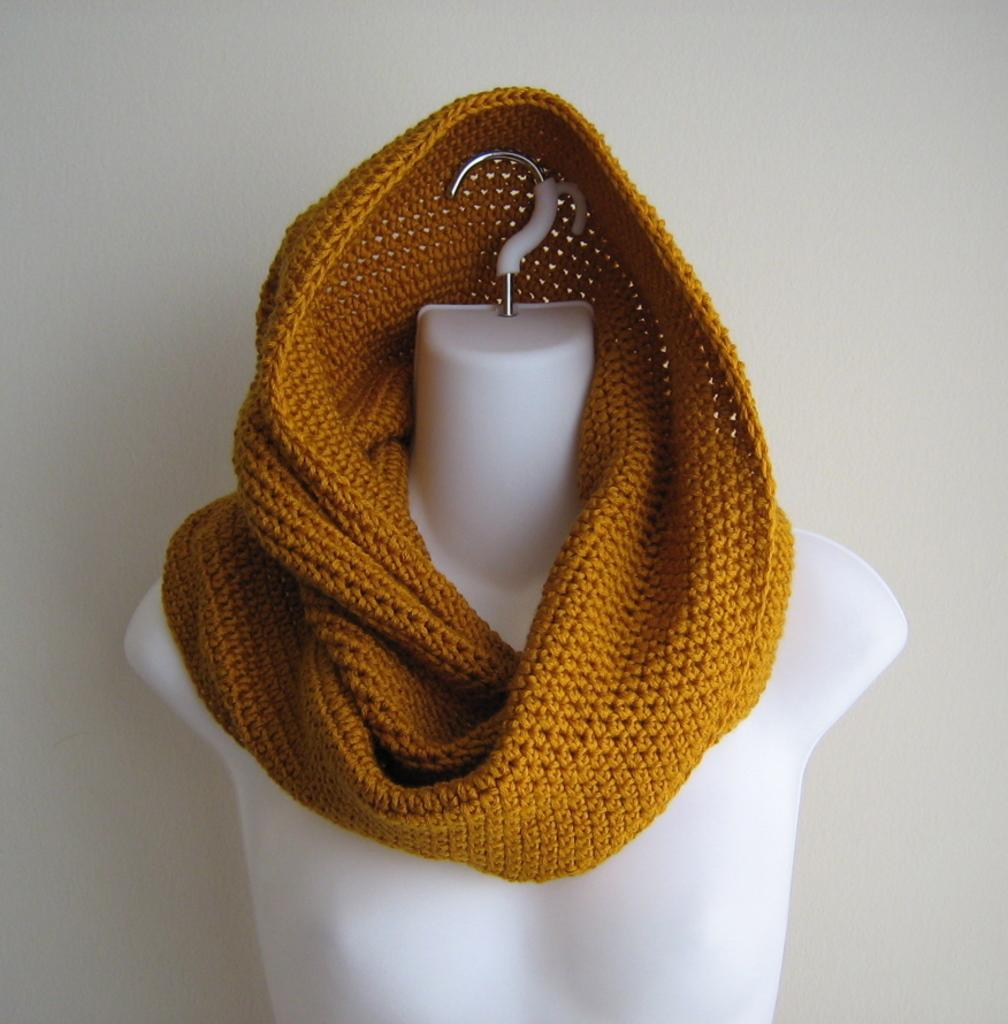What color is the scarf in the image? The scarf in the image is brown. What is the scarf placed on in the image? The scarf is on a mannequin. What can be seen in the background of the image? There is a wall in the background of the image. What type of scent can be detected from the scarf in the image? There is no information about the scent of the scarf in the image, as it only provides visual details. 